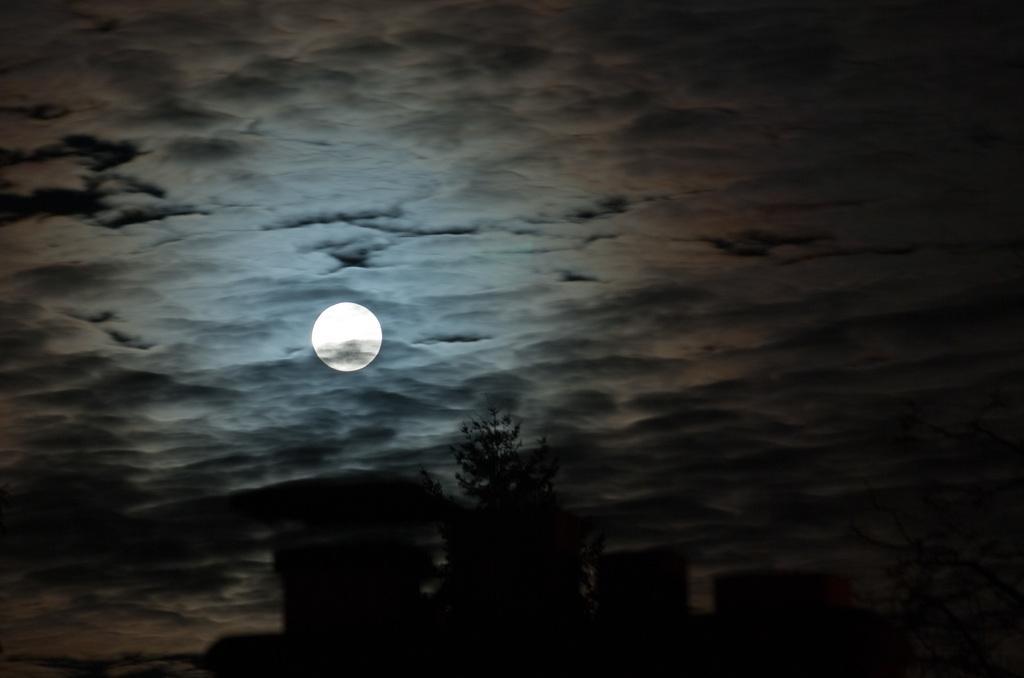In one or two sentences, can you explain what this image depicts? In this image I can see a tree and few other object's shadow. In the background I can see the moon which is white in color and the sky. 